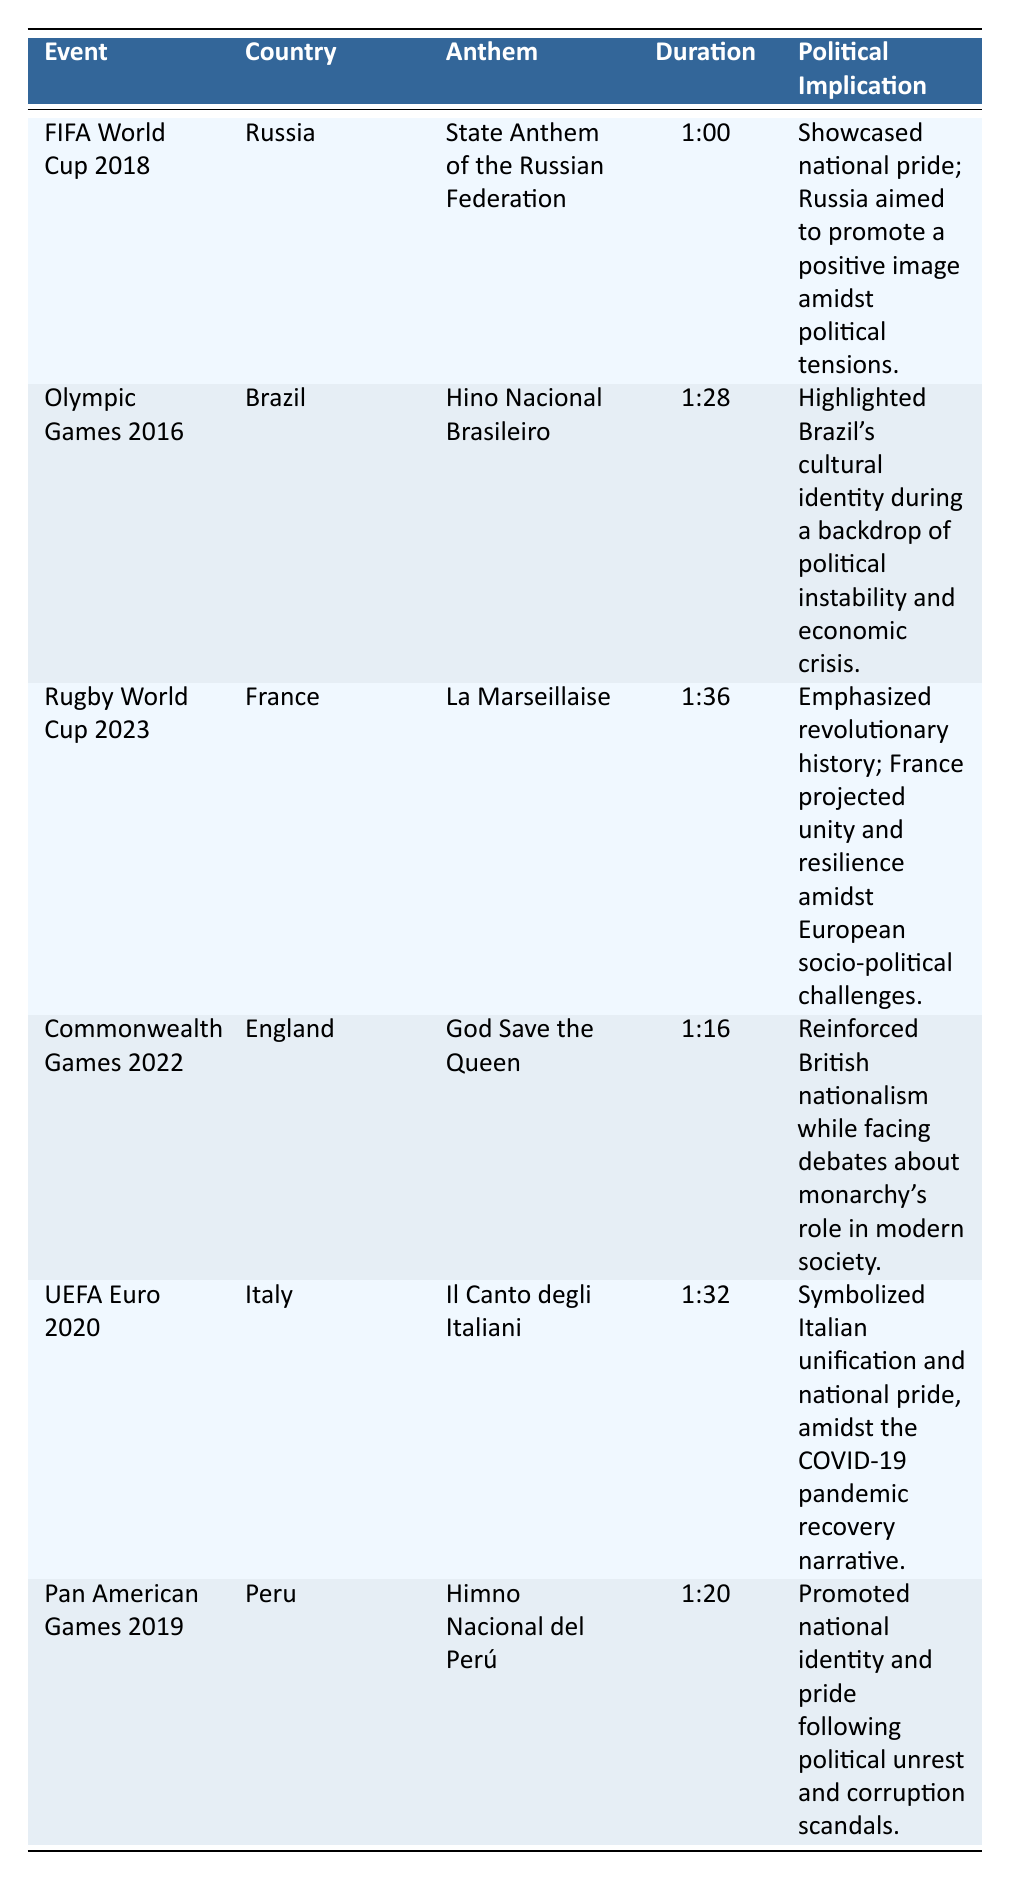What is the duration of the anthem played at the FIFA World Cup 2018? The table lists the duration of the anthem for the FIFA World Cup 2018 as 1:00. Therefore, this information can be directly retrieved from the "Duration" column corresponding to the "FIFA World Cup 2018" event.
Answer: 1:00 Which country performed "Hino Nacional Brasileiro"? By looking at the table, "Hino Nacional Brasileiro" is the anthem for Brazil during the Olympic Games 2016, as indicated in the "Country" column next to the anthem's name.
Answer: Brazil True or False: The anthem "La Marseillaise" was played at the Commonwealth Games 2022. The table can be checked for the event "Commonwealth Games 2022," which shows that the anthem played was "God Save the Queen," not "La Marseillaise." Thus, the statement is false.
Answer: False What is the average duration of the anthems listed in the table? Calculate the total duration by adding each stated duration in minutes and seconds: 1:00 (60 seconds) + 1:28 (88 seconds) + 1:36 (96 seconds) + 1:16 (76 seconds) + 1:32 (92 seconds) + 1:20 (80 seconds). This gives a total of 492 seconds. Dividing by 6 anthems results in an average duration of 82 seconds, which is 1:22 (1 minute and 22 seconds).
Answer: 1:22 What political implications were highlighted by the anthem played at the UEFA Euro 2020? By examining the "Political Implication" column corresponding to the "UEFA Euro 2020" event, it states that the anthem "Il Canto degli Italiani" symbolized Italian unification and national pride during the COVID-19 pandemic recovery.
Answer: Symbolized Italian unification and national pride Which event had the longest anthem duration and what was that duration? The durations listed are 1:00, 1:28, 1:36, 1:16, 1:32, and 1:20. The longest duration is 1:36 for the Rugby World Cup 2023. By comparing these durations, it's evident that 1:36 is the greatest.
Answer: Rugby World Cup 2023, 1:36 